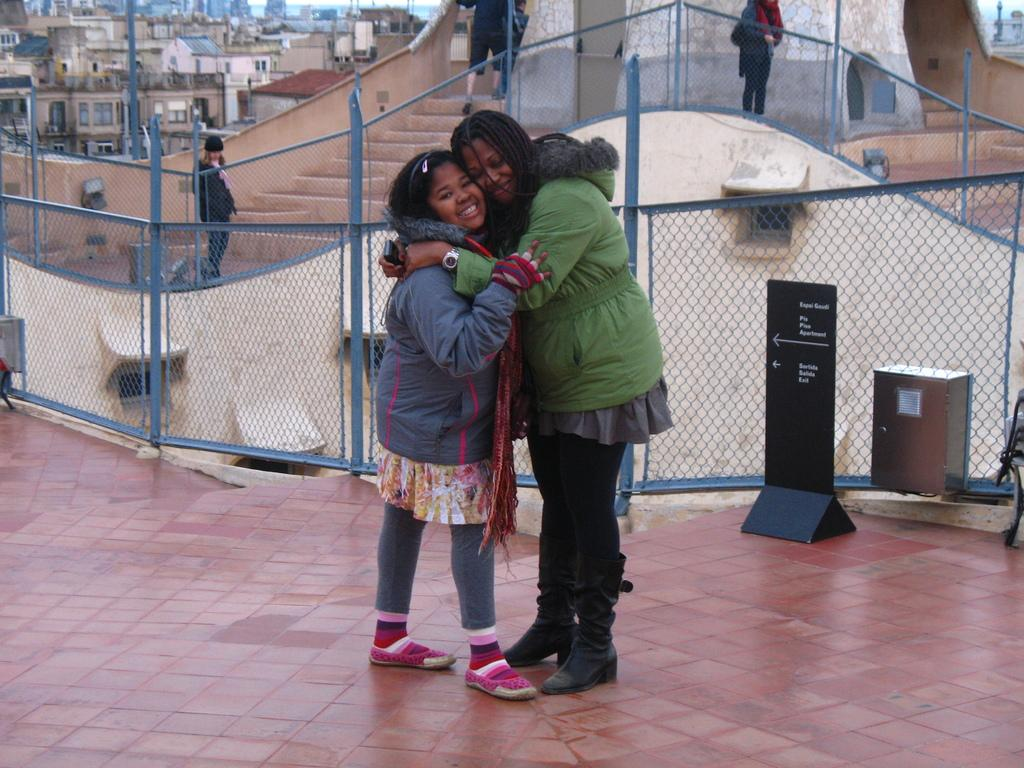What are the two people in the image doing? The two people in the image are hugging each other. What are the two people wearing? The two people are wearing jackets. Can you describe the background of the image? There are other people standing in the background, and there are multiple buildings visible as well. How many children are playing with the fog in the image? There are no children or fog present in the image. Is there a camera visible in the image? There is no camera visible in the image. 